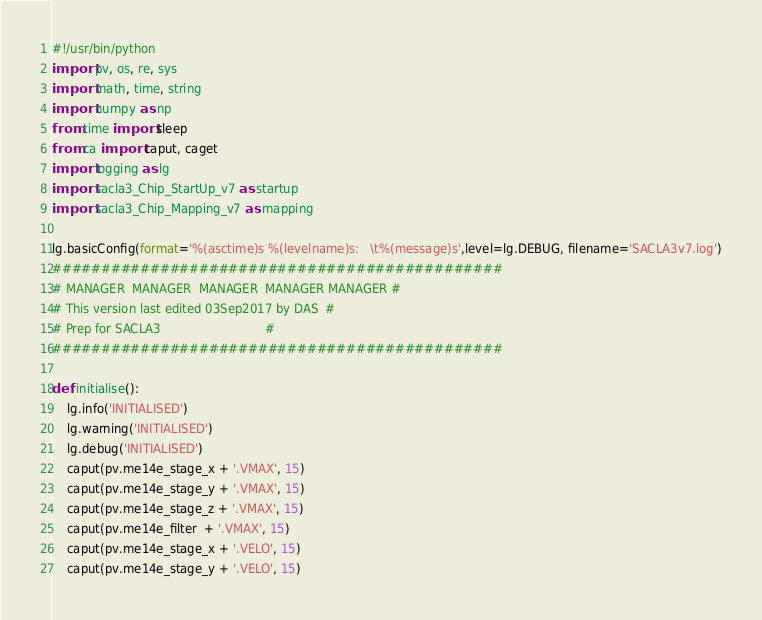<code> <loc_0><loc_0><loc_500><loc_500><_Python_>#!/usr/bin/python
import pv, os, re, sys
import math, time, string
import numpy as np
from time import sleep
from ca import caput, caget
import logging as lg
import sacla3_Chip_StartUp_v7 as startup
import sacla3_Chip_Mapping_v7 as mapping

lg.basicConfig(format='%(asctime)s %(levelname)s:   \t%(message)s',level=lg.DEBUG, filename='SACLA3v7.log')
##############################################
# MANAGER  MANAGER  MANAGER  MANAGER MANAGER # 
# This version last edited 03Sep2017 by DAS  #
# Prep for SACLA3                            #
##############################################

def initialise():
    lg.info('INITIALISED')
    lg.warning('INITIALISED')
    lg.debug('INITIALISED')
    caput(pv.me14e_stage_x + '.VMAX', 15)
    caput(pv.me14e_stage_y + '.VMAX', 15)
    caput(pv.me14e_stage_z + '.VMAX', 15)
    caput(pv.me14e_filter  + '.VMAX', 15)
    caput(pv.me14e_stage_x + '.VELO', 15)
    caput(pv.me14e_stage_y + '.VELO', 15)</code> 